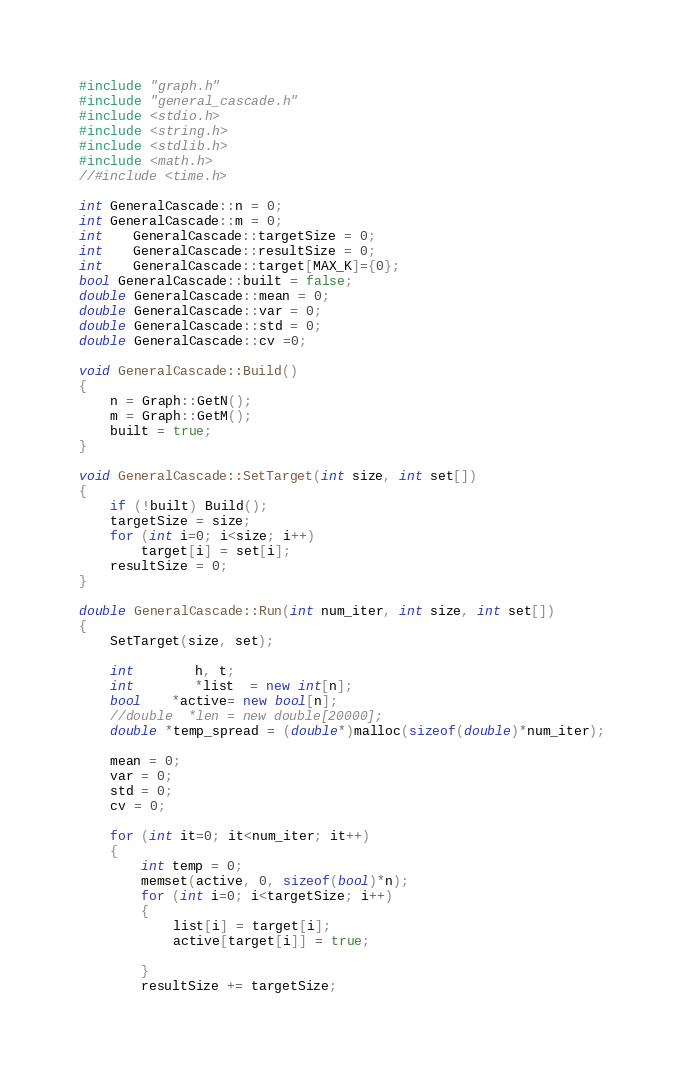<code> <loc_0><loc_0><loc_500><loc_500><_C++_>#include "graph.h"
#include "general_cascade.h"
#include <stdio.h>
#include <string.h>
#include <stdlib.h>
#include <math.h>
//#include <time.h>

int GeneralCascade::n = 0;
int GeneralCascade::m = 0;
int	GeneralCascade::targetSize = 0;
int	GeneralCascade::resultSize = 0;
int	GeneralCascade::target[MAX_K]={0};
bool GeneralCascade::built = false;
double GeneralCascade::mean = 0;
double GeneralCascade::var = 0;
double GeneralCascade::std = 0;
double GeneralCascade::cv =0;

void GeneralCascade::Build()
{
	n = Graph::GetN();
	m = Graph::GetM();
	built = true;
}

void GeneralCascade::SetTarget(int size, int set[])
{
	if (!built) Build();
	targetSize = size;
	for (int i=0; i<size; i++)
		target[i] = set[i];
	resultSize = 0;
}

double GeneralCascade::Run(int num_iter, int size, int set[])
{
	SetTarget(size, set);

	int		h, t;
	int		*list  = new int[n];
	bool	*active= new bool[n];
	//double  *len = new double[20000];
	double *temp_spread = (double*)malloc(sizeof(double)*num_iter);

	mean = 0; 
	var = 0;
	std = 0;
	cv = 0;

	for (int it=0; it<num_iter; it++)
	{
		int temp = 0;
		memset(active, 0, sizeof(bool)*n);
		for (int i=0; i<targetSize; i++) 
		{
			list[i] = target[i];
			active[target[i]] = true;
			
		}
		resultSize += targetSize;
</code> 